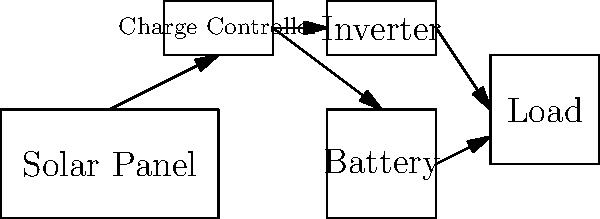As an archaeologist planning a remote dig site, you need to design a portable solar power system. Based on the schematic provided, what is the primary function of the charge controller in this setup, and why is it crucial for the system's efficiency and longevity? To understand the function of the charge controller in this portable solar power system, let's break down the components and their roles:

1. Solar Panel: Converts sunlight into electrical energy.
2. Battery: Stores excess energy for use when sunlight is unavailable.
3. Charge Controller: Regulates the flow of electricity between the solar panel and the battery.
4. Inverter: Converts DC power from the battery to AC power for most electronic devices.
5. Load: Represents the electrical devices used at the dig site.

The charge controller's primary functions are:

a) Overcharge protection: It prevents the battery from being overcharged by the solar panel. This is crucial because overcharging can damage the battery, reducing its lifespan and efficiency.

b) Deep discharge protection: It prevents the battery from being completely drained, which can also damage the battery and shorten its life.

c) Voltage regulation: It ensures that the voltage from the solar panel is appropriate for charging the battery, as solar panel output can fluctuate based on sunlight intensity.

d) Current regulation: It manages the amount of current flowing into the battery to optimize charging and prevent damage.

e) Maximum Power Point Tracking (MPPT): Advanced charge controllers use MPPT to maximize the power output from the solar panel under varying conditions.

The charge controller is crucial for the system's efficiency and longevity because:

1. It protects the battery from damage, ensuring it lasts longer and performs better throughout the dig.
2. It optimizes the charging process, making the most of available solar energy.
3. It improves overall system efficiency by managing power flow between components.
4. It prevents power wastage and potential safety hazards from overcharging or over-discharging.

In a remote archaeological dig site, where equipment reliability is paramount and replacements may be difficult to obtain, the charge controller plays a vital role in maintaining the solar power system's performance and extending its operational life.
Answer: The charge controller regulates power flow between solar panel and battery, protecting against overcharging and deep discharging, thus ensuring system efficiency and longevity. 